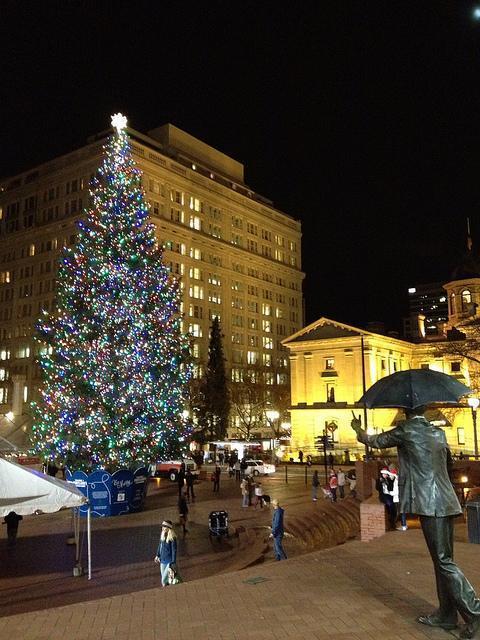How many buildings are visible in this picture?
Give a very brief answer. 2. How many people are there?
Give a very brief answer. 2. How many beds are in the room?
Give a very brief answer. 0. 